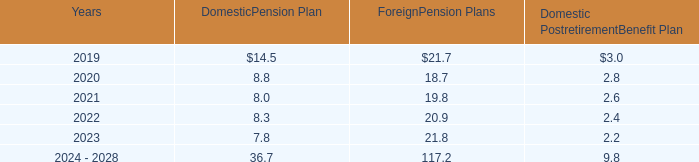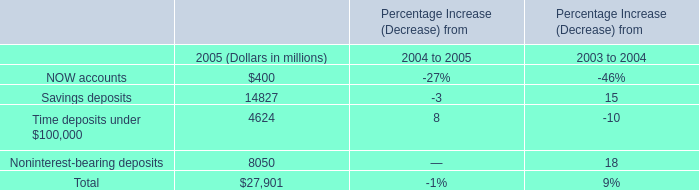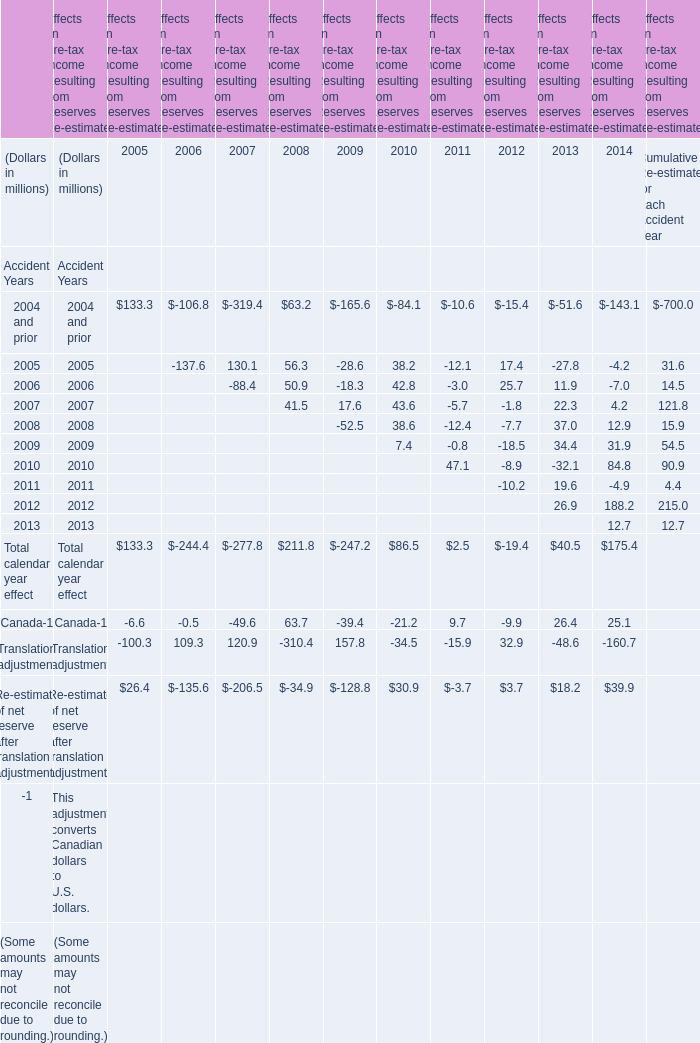How many elements show negative value in 2005 for Effects on Pre-tax Income Resulting from Reserves Re-estimates? 
Answer: 2. 